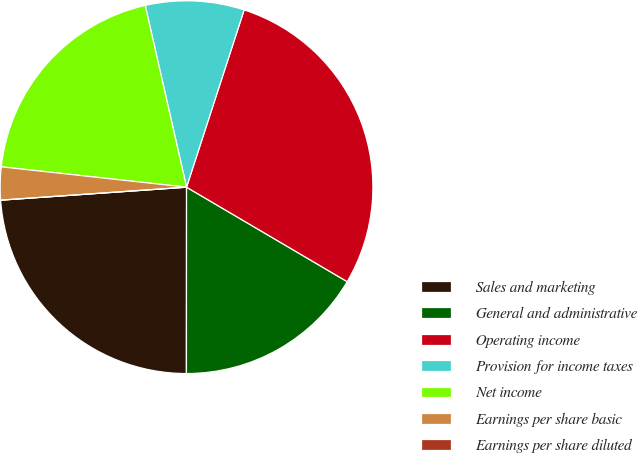<chart> <loc_0><loc_0><loc_500><loc_500><pie_chart><fcel>Sales and marketing<fcel>General and administrative<fcel>Operating income<fcel>Provision for income taxes<fcel>Net income<fcel>Earnings per share basic<fcel>Earnings per share diluted<nl><fcel>23.88%<fcel>16.55%<fcel>28.46%<fcel>8.56%<fcel>19.7%<fcel>2.85%<fcel>0.0%<nl></chart> 